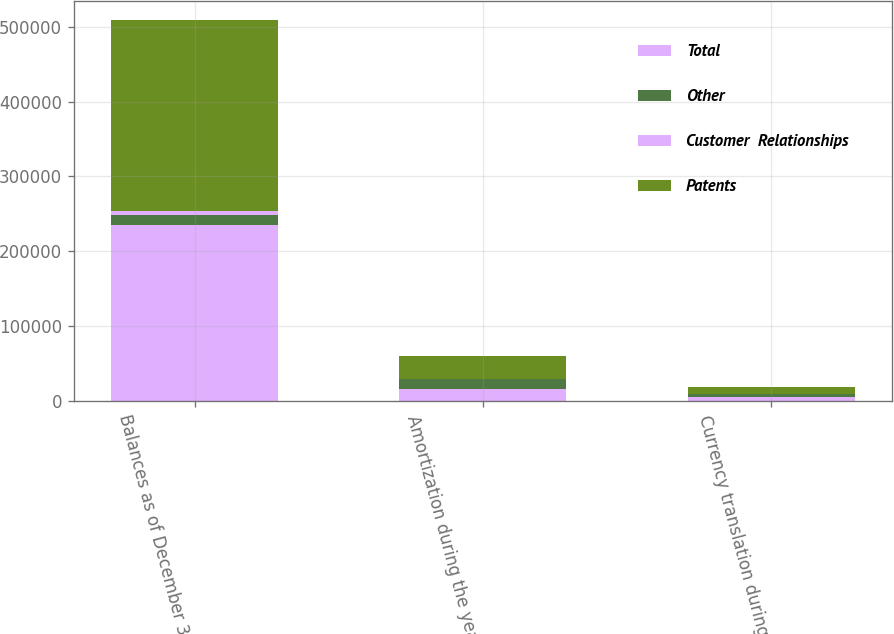Convert chart to OTSL. <chart><loc_0><loc_0><loc_500><loc_500><stacked_bar_chart><ecel><fcel>Balances as of December 31<fcel>Amortization during the year<fcel>Currency translation during<nl><fcel>Total<fcel>235704<fcel>16567<fcel>5102<nl><fcel>Other<fcel>13424<fcel>13331<fcel>4275<nl><fcel>Customer  Relationships<fcel>5331<fcel>11<fcel>5<nl><fcel>Patents<fcel>254459<fcel>29909<fcel>9382<nl></chart> 